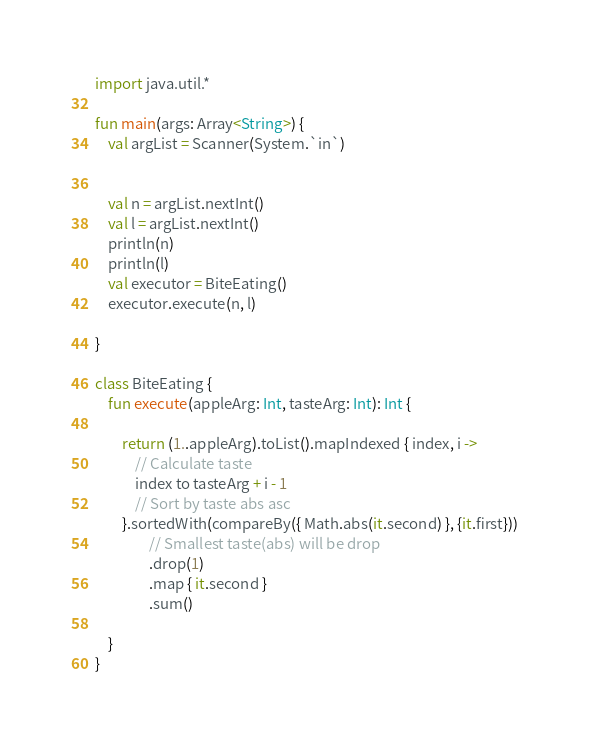Convert code to text. <code><loc_0><loc_0><loc_500><loc_500><_Kotlin_>import java.util.*

fun main(args: Array<String>) {
    val argList = Scanner(System.`in`)


    val n = argList.nextInt()
    val l = argList.nextInt()
    println(n)
    println(l)
    val executor = BiteEating()
    executor.execute(n, l)

}

class BiteEating {
    fun execute(appleArg: Int, tasteArg: Int): Int {

        return (1..appleArg).toList().mapIndexed { index, i ->
            // Calculate taste
            index to tasteArg + i - 1
            // Sort by taste abs asc
        }.sortedWith(compareBy({ Math.abs(it.second) }, {it.first}))
                // Smallest taste(abs) will be drop
                .drop(1)
                .map { it.second }
                .sum()

    }
}</code> 